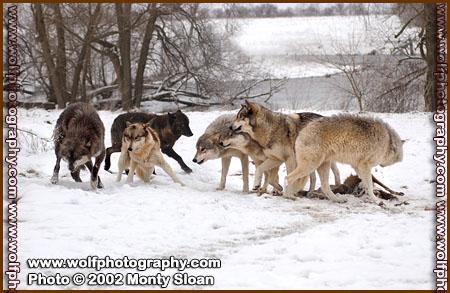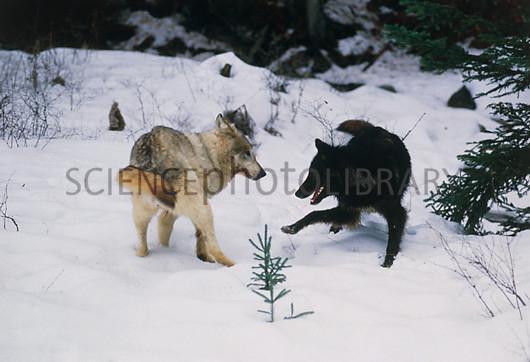The first image is the image on the left, the second image is the image on the right. Considering the images on both sides, is "An image shows exactly two different colored wolves interacting playfully in the snow, one with its rear toward the camera." valid? Answer yes or no. Yes. The first image is the image on the left, the second image is the image on the right. Examine the images to the left and right. Is the description "Two dogs are standing in the snow in the image on the right." accurate? Answer yes or no. Yes. 